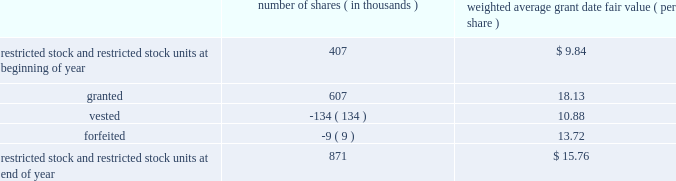Abiomed , inc .
And subsidiaries notes to consolidated financial statements 2014 ( continued ) note 8 .
Stock award plans and stock-based compensation ( continued ) restricted stock and restricted stock units the table summarizes restricted stock and restricted stock unit activity for the fiscal year ended march 31 , 2012 : number of shares ( in thousands ) weighted average grant date fair value ( per share ) .
The remaining unrecognized compensation expense for outstanding restricted stock and restricted stock units , including performance-based awards , as of march 31 , 2012 was $ 7.1 million and the weighted-average period over which this cost will be recognized is 2.2 years .
The weighted average grant-date fair value for restricted stock and restricted stock units granted during the years ended march 31 , 2012 , 2011 , and 2010 was $ 18.13 , $ 10.00 and $ 7.67 per share , respectively .
The total fair value of restricted stock and restricted stock units vested in fiscal years 2012 , 2011 , and 2010 was $ 1.5 million , $ 1.0 million and $ 0.4 million , respectively .
Performance-based awards included in the restricted stock and restricted stock units activity discussed above are certain awards granted in fiscal years 2012 , 2011 and 2010 that vest subject to certain performance-based criteria .
In june 2010 , 311000 shares of restricted stock and a performance-based award for the potential issuance of 45000 shares of common stock were issued to certain executive officers and members of senior management of the company , all of which would vest upon achievement of prescribed service milestones by the award recipients and performance milestones by the company .
During the year ended march 31 , 2011 , the company determined that it met the prescribed performance targets and a portion of these shares and stock options vested .
The remaining shares will vest upon satisfaction of prescribed service conditions by the award recipients .
During the three months ended june 30 , 2011 , the company determined that it should have been using the graded vesting method instead of the straight-line method to expense stock-based compensation for the performance-based awards issued in june 2010 .
This resulted in additional stock based compensation expense of approximately $ 0.6 million being recorded during the three months ended june 30 , 2011 that should have been recorded during the year ended march 31 , 2011 .
The company believes that the amount is not material to its march 31 , 2011 consolidated financial statements and therefore recorded the adjustment in the quarter ended june 30 , 2011 .
During the three months ended june 30 , 2011 , performance-based awards of restricted stock units for the potential issuance of 284000 shares of common stock were issued to certain executive officers and members of the senior management , all of which would vest upon achievement of prescribed service milestones by the award recipients and revenue performance milestones by the company .
As of march 31 , 2012 , the company determined that it met the prescribed targets for 184000 shares underlying these awards and it believes it is probable that the prescribed performance targets will be met for the remaining 100000 shares , and the compensation expense is being recognized accordingly .
During the year ended march 31 , 2012 , the company has recorded $ 3.3 million in stock-based compensation expense for equity awards in which the prescribed performance milestones have been achieved or are probable of being achieved .
The remaining unrecognized compensation expense related to these equity awards at march 31 , 2012 is $ 3.6 million based on the company 2019s current assessment of probability of achieving the performance milestones .
The weighted-average period over which this cost will be recognized is 2.1 years. .
What is the net change in the number of shares for restricted stock and restricted stock units during fiscal year ended march 31 , 2012? 
Computations: (871 - 407)
Answer: 464.0. 